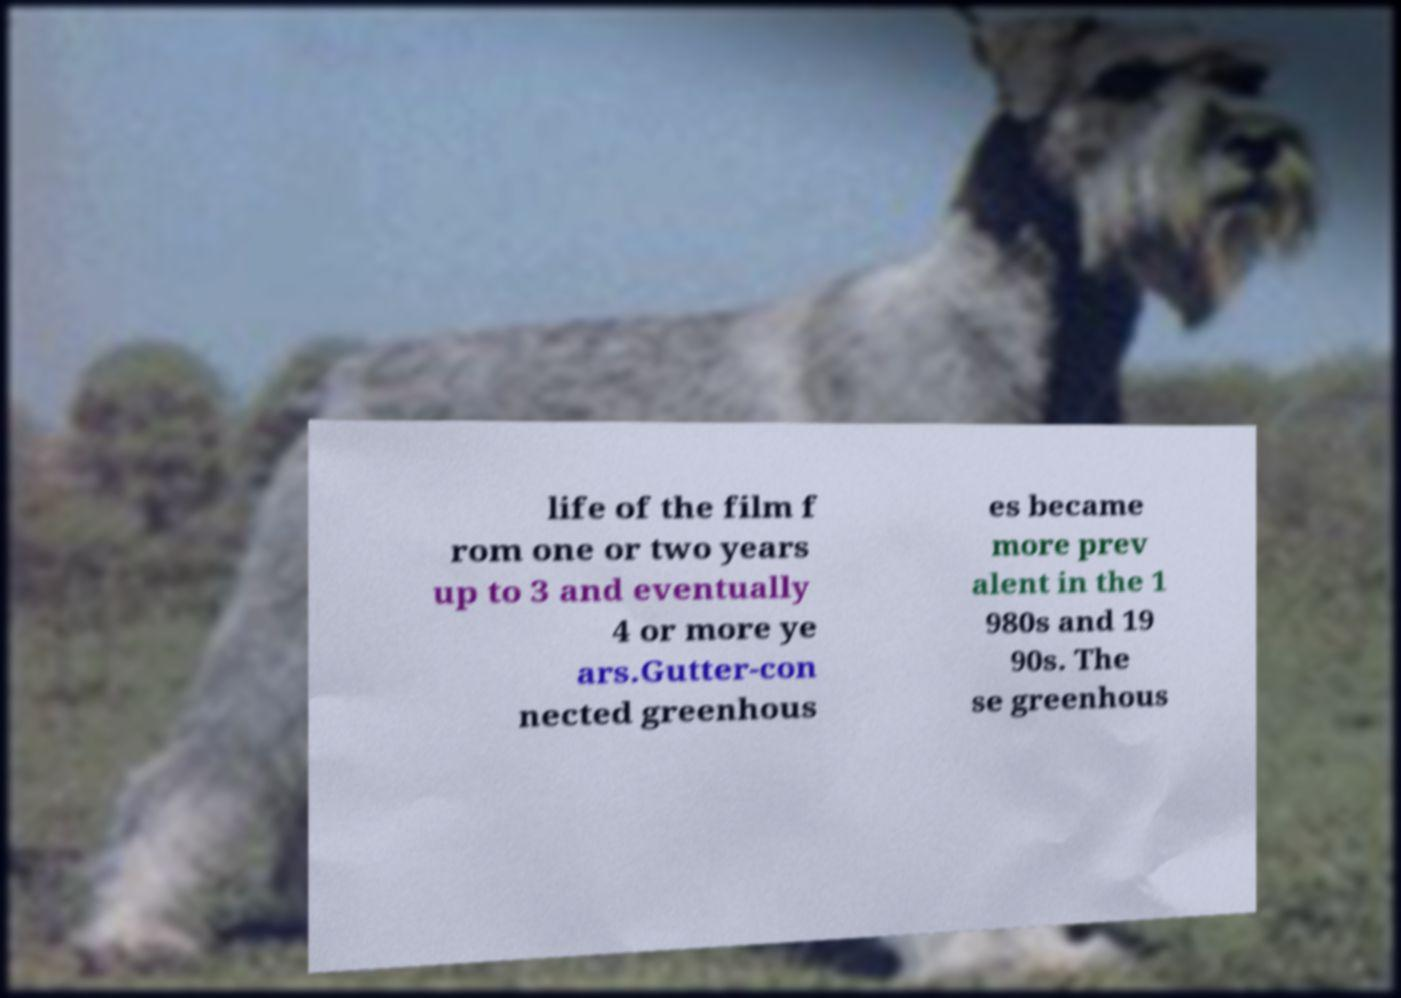For documentation purposes, I need the text within this image transcribed. Could you provide that? life of the film f rom one or two years up to 3 and eventually 4 or more ye ars.Gutter-con nected greenhous es became more prev alent in the 1 980s and 19 90s. The se greenhous 